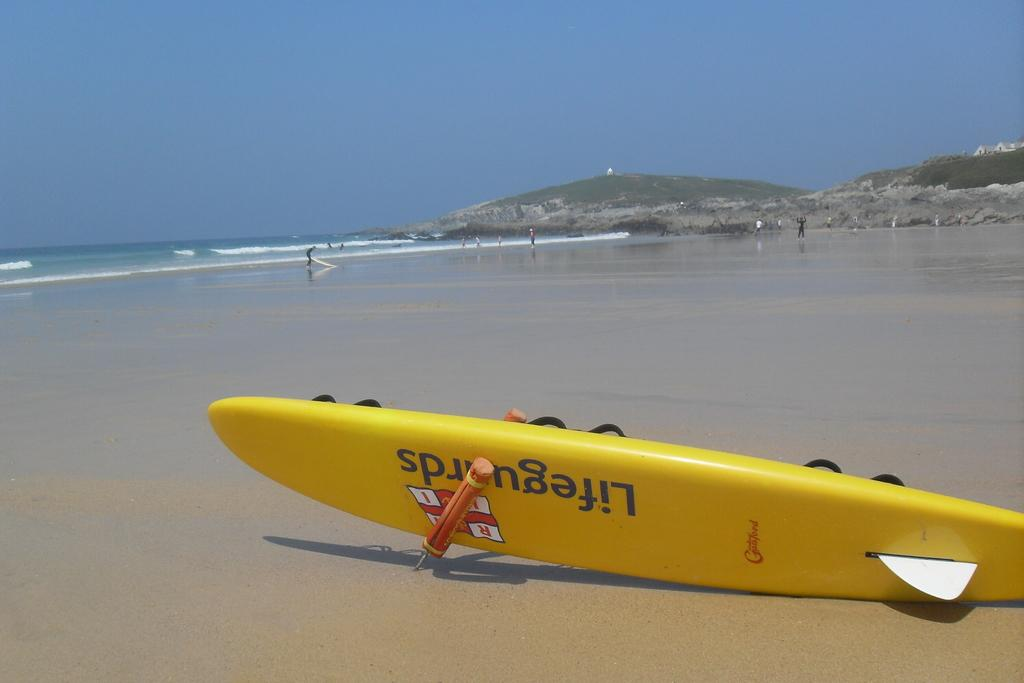<image>
Relay a brief, clear account of the picture shown. Long yellow boat on the sand that says "Lifeguards" on it. 